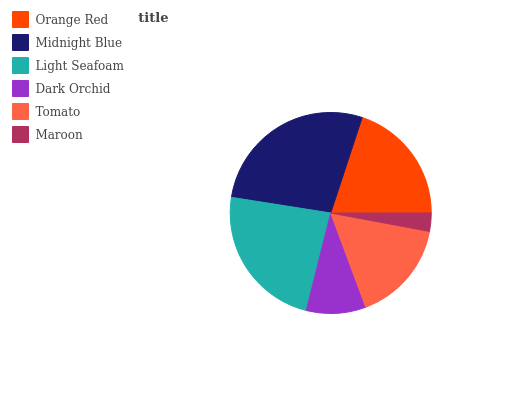Is Maroon the minimum?
Answer yes or no. Yes. Is Midnight Blue the maximum?
Answer yes or no. Yes. Is Light Seafoam the minimum?
Answer yes or no. No. Is Light Seafoam the maximum?
Answer yes or no. No. Is Midnight Blue greater than Light Seafoam?
Answer yes or no. Yes. Is Light Seafoam less than Midnight Blue?
Answer yes or no. Yes. Is Light Seafoam greater than Midnight Blue?
Answer yes or no. No. Is Midnight Blue less than Light Seafoam?
Answer yes or no. No. Is Orange Red the high median?
Answer yes or no. Yes. Is Tomato the low median?
Answer yes or no. Yes. Is Maroon the high median?
Answer yes or no. No. Is Light Seafoam the low median?
Answer yes or no. No. 